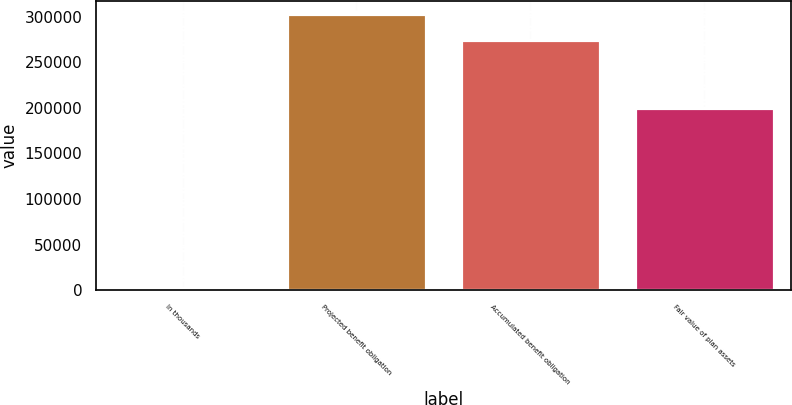Convert chart to OTSL. <chart><loc_0><loc_0><loc_500><loc_500><bar_chart><fcel>In thousands<fcel>Projected benefit obligation<fcel>Accumulated benefit obligation<fcel>Fair value of plan assets<nl><fcel>2017<fcel>302563<fcel>274557<fcel>200218<nl></chart> 